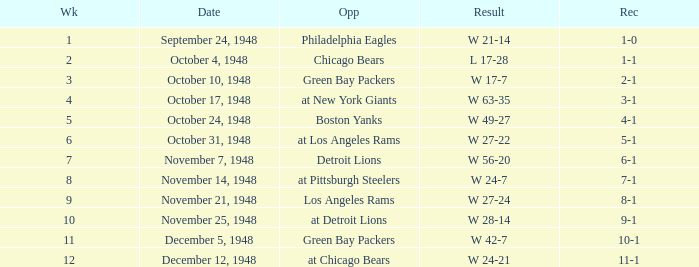What date was the opponent the Boston Yanks? October 24, 1948. 